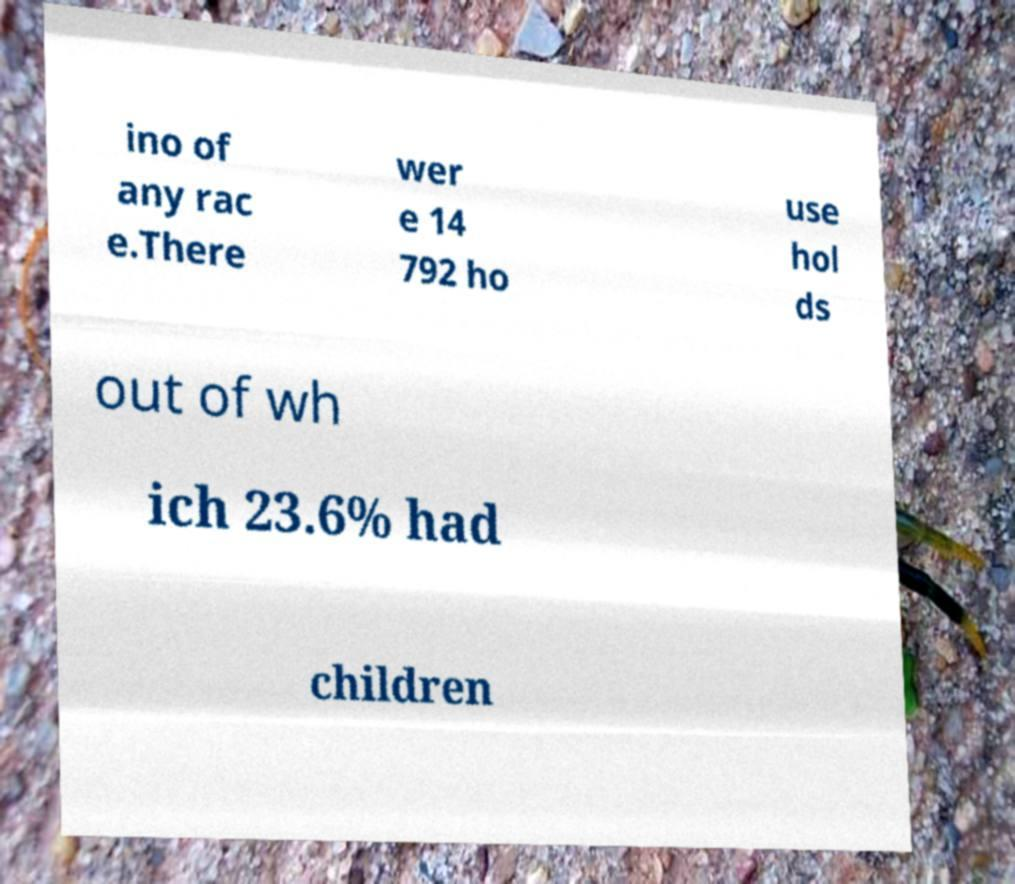What messages or text are displayed in this image? I need them in a readable, typed format. ino of any rac e.There wer e 14 792 ho use hol ds out of wh ich 23.6% had children 